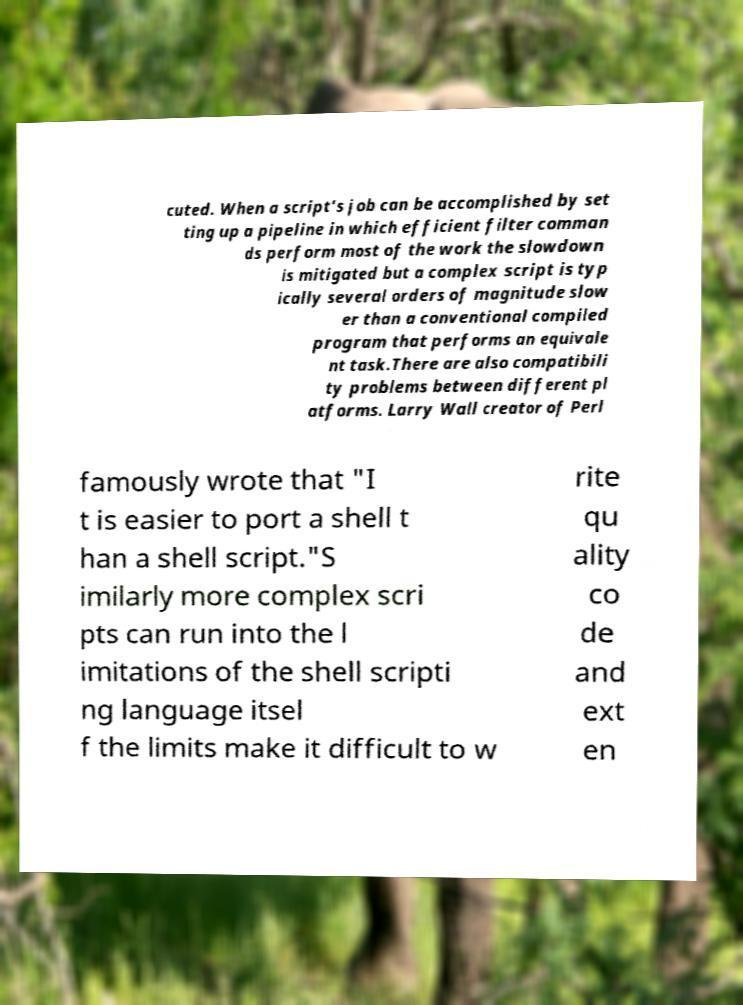Could you assist in decoding the text presented in this image and type it out clearly? cuted. When a script's job can be accomplished by set ting up a pipeline in which efficient filter comman ds perform most of the work the slowdown is mitigated but a complex script is typ ically several orders of magnitude slow er than a conventional compiled program that performs an equivale nt task.There are also compatibili ty problems between different pl atforms. Larry Wall creator of Perl famously wrote that "I t is easier to port a shell t han a shell script."S imilarly more complex scri pts can run into the l imitations of the shell scripti ng language itsel f the limits make it difficult to w rite qu ality co de and ext en 